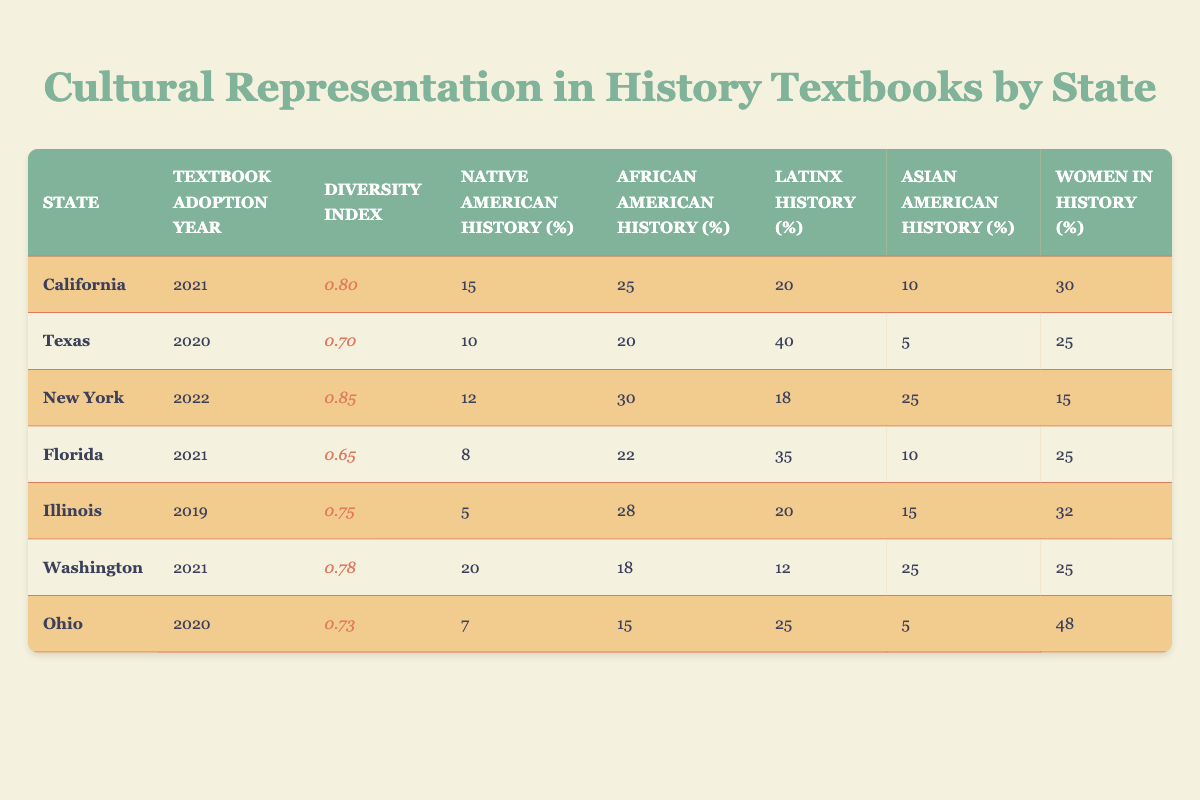What is the Diversity Index for New York? The Diversity Index for New York is clearly indicated in the table under the corresponding column. By looking at the row for New York, we can directly see the value listed as 0.85.
Answer: 0.85 Which state has the highest percentage of Women in History? To find the state with the highest percentage of Women in History, we can compare the percentages listed for each state in the corresponding column. The highest value appears in the row for Ohio, which has 48%.
Answer: Ohio What is the average percentage of African American History across all states? We need to sum the percentages of African American History from each state. The values are 25 (California), 20 (Texas), 30 (New York), 22 (Florida), 28 (Illinois), 18 (Washington), and 15 (Ohio). Adding these gives us a total of 168. There are 7 states, so the average percentage is 168/7, which equals approximately 24%.
Answer: 24% Is the Percentage of Latinx History higher in Texas than in California? In the table, Texas has a percentage of 40% for Latinx History while California has 20%. Comparing these two values, it is clear that 40% is greater than 20%. Therefore, the statement is true.
Answer: Yes What is the difference in the Diversity Index between New York and Florida? The Diversity Index for New York is 0.85, and for Florida, it is 0.65. To find the difference, we subtract Florida's index from New York's index: 0.85 - 0.65 = 0.20. This means the difference in the Diversity Index is 0.20.
Answer: 0.20 Which state has the lowest percentage of Native American History? By examining the values for Native American History, we can see they are 15 (California), 10 (Texas), 12 (New York), 8 (Florida), 5 (Illinois), 20 (Washington), and 7 (Ohio). The lowest value can be clearly identified in the Illinois row, which has 5%.
Answer: Illinois 